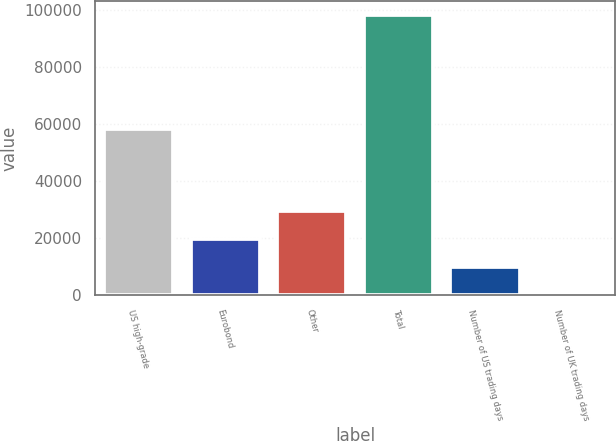Convert chart. <chart><loc_0><loc_0><loc_500><loc_500><bar_chart><fcel>US high-grade<fcel>Eurobond<fcel>Other<fcel>Total<fcel>Number of US trading days<fcel>Number of UK trading days<nl><fcel>58170<fcel>19705<fcel>29527<fcel>98281<fcel>9883<fcel>61<nl></chart> 